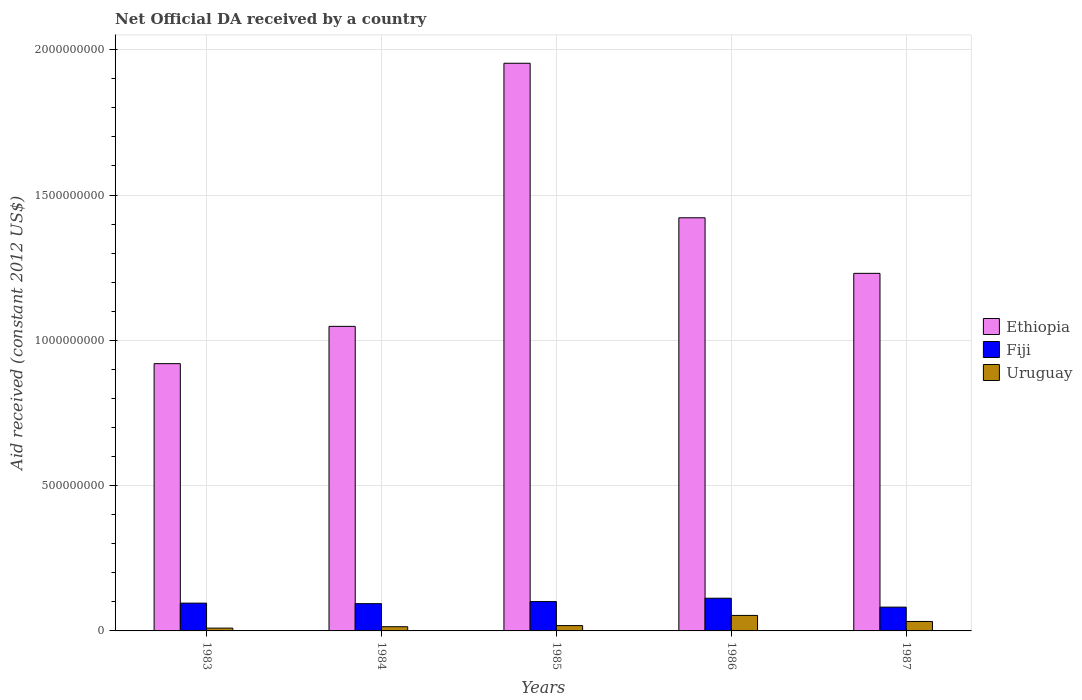How many groups of bars are there?
Give a very brief answer. 5. Are the number of bars on each tick of the X-axis equal?
Give a very brief answer. Yes. How many bars are there on the 2nd tick from the right?
Give a very brief answer. 3. What is the label of the 3rd group of bars from the left?
Give a very brief answer. 1985. In how many cases, is the number of bars for a given year not equal to the number of legend labels?
Give a very brief answer. 0. What is the net official development assistance aid received in Ethiopia in 1985?
Provide a succinct answer. 1.95e+09. Across all years, what is the maximum net official development assistance aid received in Ethiopia?
Give a very brief answer. 1.95e+09. Across all years, what is the minimum net official development assistance aid received in Ethiopia?
Give a very brief answer. 9.20e+08. In which year was the net official development assistance aid received in Fiji maximum?
Provide a succinct answer. 1986. What is the total net official development assistance aid received in Uruguay in the graph?
Offer a very short reply. 1.28e+08. What is the difference between the net official development assistance aid received in Fiji in 1983 and that in 1987?
Provide a succinct answer. 1.38e+07. What is the difference between the net official development assistance aid received in Ethiopia in 1985 and the net official development assistance aid received in Uruguay in 1984?
Make the answer very short. 1.94e+09. What is the average net official development assistance aid received in Fiji per year?
Your answer should be very brief. 9.70e+07. In the year 1987, what is the difference between the net official development assistance aid received in Uruguay and net official development assistance aid received in Ethiopia?
Provide a short and direct response. -1.20e+09. In how many years, is the net official development assistance aid received in Ethiopia greater than 800000000 US$?
Give a very brief answer. 5. What is the ratio of the net official development assistance aid received in Uruguay in 1983 to that in 1985?
Ensure brevity in your answer.  0.53. Is the net official development assistance aid received in Fiji in 1985 less than that in 1987?
Provide a succinct answer. No. Is the difference between the net official development assistance aid received in Uruguay in 1983 and 1986 greater than the difference between the net official development assistance aid received in Ethiopia in 1983 and 1986?
Provide a succinct answer. Yes. What is the difference between the highest and the second highest net official development assistance aid received in Fiji?
Provide a succinct answer. 1.15e+07. What is the difference between the highest and the lowest net official development assistance aid received in Uruguay?
Make the answer very short. 4.37e+07. Is the sum of the net official development assistance aid received in Fiji in 1986 and 1987 greater than the maximum net official development assistance aid received in Uruguay across all years?
Offer a terse response. Yes. What does the 1st bar from the left in 1984 represents?
Your answer should be very brief. Ethiopia. What does the 2nd bar from the right in 1986 represents?
Ensure brevity in your answer.  Fiji. Is it the case that in every year, the sum of the net official development assistance aid received in Fiji and net official development assistance aid received in Uruguay is greater than the net official development assistance aid received in Ethiopia?
Give a very brief answer. No. How many bars are there?
Make the answer very short. 15. How many years are there in the graph?
Your answer should be very brief. 5. Does the graph contain any zero values?
Offer a terse response. No. What is the title of the graph?
Your answer should be compact. Net Official DA received by a country. Does "Zambia" appear as one of the legend labels in the graph?
Your response must be concise. No. What is the label or title of the X-axis?
Your answer should be compact. Years. What is the label or title of the Y-axis?
Keep it short and to the point. Aid received (constant 2012 US$). What is the Aid received (constant 2012 US$) in Ethiopia in 1983?
Give a very brief answer. 9.20e+08. What is the Aid received (constant 2012 US$) of Fiji in 1983?
Ensure brevity in your answer.  9.56e+07. What is the Aid received (constant 2012 US$) in Uruguay in 1983?
Ensure brevity in your answer.  9.64e+06. What is the Aid received (constant 2012 US$) in Ethiopia in 1984?
Ensure brevity in your answer.  1.05e+09. What is the Aid received (constant 2012 US$) in Fiji in 1984?
Your response must be concise. 9.38e+07. What is the Aid received (constant 2012 US$) of Uruguay in 1984?
Your answer should be compact. 1.44e+07. What is the Aid received (constant 2012 US$) in Ethiopia in 1985?
Give a very brief answer. 1.95e+09. What is the Aid received (constant 2012 US$) in Fiji in 1985?
Provide a succinct answer. 1.01e+08. What is the Aid received (constant 2012 US$) in Uruguay in 1985?
Offer a very short reply. 1.83e+07. What is the Aid received (constant 2012 US$) in Ethiopia in 1986?
Ensure brevity in your answer.  1.42e+09. What is the Aid received (constant 2012 US$) of Fiji in 1986?
Your answer should be very brief. 1.13e+08. What is the Aid received (constant 2012 US$) in Uruguay in 1986?
Ensure brevity in your answer.  5.34e+07. What is the Aid received (constant 2012 US$) of Ethiopia in 1987?
Offer a very short reply. 1.23e+09. What is the Aid received (constant 2012 US$) of Fiji in 1987?
Offer a terse response. 8.18e+07. What is the Aid received (constant 2012 US$) in Uruguay in 1987?
Offer a very short reply. 3.25e+07. Across all years, what is the maximum Aid received (constant 2012 US$) in Ethiopia?
Your response must be concise. 1.95e+09. Across all years, what is the maximum Aid received (constant 2012 US$) of Fiji?
Your response must be concise. 1.13e+08. Across all years, what is the maximum Aid received (constant 2012 US$) in Uruguay?
Offer a terse response. 5.34e+07. Across all years, what is the minimum Aid received (constant 2012 US$) of Ethiopia?
Provide a short and direct response. 9.20e+08. Across all years, what is the minimum Aid received (constant 2012 US$) of Fiji?
Your response must be concise. 8.18e+07. Across all years, what is the minimum Aid received (constant 2012 US$) of Uruguay?
Offer a very short reply. 9.64e+06. What is the total Aid received (constant 2012 US$) in Ethiopia in the graph?
Your answer should be very brief. 6.57e+09. What is the total Aid received (constant 2012 US$) of Fiji in the graph?
Make the answer very short. 4.85e+08. What is the total Aid received (constant 2012 US$) of Uruguay in the graph?
Your answer should be very brief. 1.28e+08. What is the difference between the Aid received (constant 2012 US$) in Ethiopia in 1983 and that in 1984?
Keep it short and to the point. -1.28e+08. What is the difference between the Aid received (constant 2012 US$) of Fiji in 1983 and that in 1984?
Provide a succinct answer. 1.80e+06. What is the difference between the Aid received (constant 2012 US$) in Uruguay in 1983 and that in 1984?
Offer a terse response. -4.81e+06. What is the difference between the Aid received (constant 2012 US$) in Ethiopia in 1983 and that in 1985?
Provide a succinct answer. -1.03e+09. What is the difference between the Aid received (constant 2012 US$) in Fiji in 1983 and that in 1985?
Your answer should be compact. -5.38e+06. What is the difference between the Aid received (constant 2012 US$) of Uruguay in 1983 and that in 1985?
Your response must be concise. -8.65e+06. What is the difference between the Aid received (constant 2012 US$) in Ethiopia in 1983 and that in 1986?
Provide a short and direct response. -5.02e+08. What is the difference between the Aid received (constant 2012 US$) in Fiji in 1983 and that in 1986?
Your answer should be very brief. -1.69e+07. What is the difference between the Aid received (constant 2012 US$) of Uruguay in 1983 and that in 1986?
Offer a terse response. -4.37e+07. What is the difference between the Aid received (constant 2012 US$) in Ethiopia in 1983 and that in 1987?
Your answer should be very brief. -3.11e+08. What is the difference between the Aid received (constant 2012 US$) in Fiji in 1983 and that in 1987?
Offer a terse response. 1.38e+07. What is the difference between the Aid received (constant 2012 US$) of Uruguay in 1983 and that in 1987?
Provide a short and direct response. -2.29e+07. What is the difference between the Aid received (constant 2012 US$) in Ethiopia in 1984 and that in 1985?
Give a very brief answer. -9.05e+08. What is the difference between the Aid received (constant 2012 US$) in Fiji in 1984 and that in 1985?
Keep it short and to the point. -7.18e+06. What is the difference between the Aid received (constant 2012 US$) in Uruguay in 1984 and that in 1985?
Your answer should be compact. -3.84e+06. What is the difference between the Aid received (constant 2012 US$) of Ethiopia in 1984 and that in 1986?
Provide a short and direct response. -3.74e+08. What is the difference between the Aid received (constant 2012 US$) in Fiji in 1984 and that in 1986?
Keep it short and to the point. -1.87e+07. What is the difference between the Aid received (constant 2012 US$) of Uruguay in 1984 and that in 1986?
Offer a terse response. -3.89e+07. What is the difference between the Aid received (constant 2012 US$) in Ethiopia in 1984 and that in 1987?
Keep it short and to the point. -1.82e+08. What is the difference between the Aid received (constant 2012 US$) of Fiji in 1984 and that in 1987?
Ensure brevity in your answer.  1.20e+07. What is the difference between the Aid received (constant 2012 US$) of Uruguay in 1984 and that in 1987?
Keep it short and to the point. -1.81e+07. What is the difference between the Aid received (constant 2012 US$) of Ethiopia in 1985 and that in 1986?
Ensure brevity in your answer.  5.32e+08. What is the difference between the Aid received (constant 2012 US$) in Fiji in 1985 and that in 1986?
Keep it short and to the point. -1.15e+07. What is the difference between the Aid received (constant 2012 US$) in Uruguay in 1985 and that in 1986?
Offer a terse response. -3.51e+07. What is the difference between the Aid received (constant 2012 US$) in Ethiopia in 1985 and that in 1987?
Offer a terse response. 7.23e+08. What is the difference between the Aid received (constant 2012 US$) in Fiji in 1985 and that in 1987?
Give a very brief answer. 1.92e+07. What is the difference between the Aid received (constant 2012 US$) in Uruguay in 1985 and that in 1987?
Offer a terse response. -1.42e+07. What is the difference between the Aid received (constant 2012 US$) in Ethiopia in 1986 and that in 1987?
Give a very brief answer. 1.91e+08. What is the difference between the Aid received (constant 2012 US$) of Fiji in 1986 and that in 1987?
Ensure brevity in your answer.  3.07e+07. What is the difference between the Aid received (constant 2012 US$) of Uruguay in 1986 and that in 1987?
Provide a succinct answer. 2.08e+07. What is the difference between the Aid received (constant 2012 US$) in Ethiopia in 1983 and the Aid received (constant 2012 US$) in Fiji in 1984?
Keep it short and to the point. 8.26e+08. What is the difference between the Aid received (constant 2012 US$) in Ethiopia in 1983 and the Aid received (constant 2012 US$) in Uruguay in 1984?
Provide a succinct answer. 9.05e+08. What is the difference between the Aid received (constant 2012 US$) in Fiji in 1983 and the Aid received (constant 2012 US$) in Uruguay in 1984?
Ensure brevity in your answer.  8.12e+07. What is the difference between the Aid received (constant 2012 US$) in Ethiopia in 1983 and the Aid received (constant 2012 US$) in Fiji in 1985?
Your answer should be compact. 8.19e+08. What is the difference between the Aid received (constant 2012 US$) in Ethiopia in 1983 and the Aid received (constant 2012 US$) in Uruguay in 1985?
Make the answer very short. 9.01e+08. What is the difference between the Aid received (constant 2012 US$) of Fiji in 1983 and the Aid received (constant 2012 US$) of Uruguay in 1985?
Make the answer very short. 7.73e+07. What is the difference between the Aid received (constant 2012 US$) in Ethiopia in 1983 and the Aid received (constant 2012 US$) in Fiji in 1986?
Offer a terse response. 8.07e+08. What is the difference between the Aid received (constant 2012 US$) of Ethiopia in 1983 and the Aid received (constant 2012 US$) of Uruguay in 1986?
Offer a very short reply. 8.66e+08. What is the difference between the Aid received (constant 2012 US$) of Fiji in 1983 and the Aid received (constant 2012 US$) of Uruguay in 1986?
Your answer should be compact. 4.22e+07. What is the difference between the Aid received (constant 2012 US$) of Ethiopia in 1983 and the Aid received (constant 2012 US$) of Fiji in 1987?
Your answer should be compact. 8.38e+08. What is the difference between the Aid received (constant 2012 US$) in Ethiopia in 1983 and the Aid received (constant 2012 US$) in Uruguay in 1987?
Give a very brief answer. 8.87e+08. What is the difference between the Aid received (constant 2012 US$) of Fiji in 1983 and the Aid received (constant 2012 US$) of Uruguay in 1987?
Keep it short and to the point. 6.31e+07. What is the difference between the Aid received (constant 2012 US$) in Ethiopia in 1984 and the Aid received (constant 2012 US$) in Fiji in 1985?
Ensure brevity in your answer.  9.47e+08. What is the difference between the Aid received (constant 2012 US$) of Ethiopia in 1984 and the Aid received (constant 2012 US$) of Uruguay in 1985?
Offer a terse response. 1.03e+09. What is the difference between the Aid received (constant 2012 US$) in Fiji in 1984 and the Aid received (constant 2012 US$) in Uruguay in 1985?
Provide a short and direct response. 7.55e+07. What is the difference between the Aid received (constant 2012 US$) of Ethiopia in 1984 and the Aid received (constant 2012 US$) of Fiji in 1986?
Offer a very short reply. 9.35e+08. What is the difference between the Aid received (constant 2012 US$) in Ethiopia in 1984 and the Aid received (constant 2012 US$) in Uruguay in 1986?
Make the answer very short. 9.95e+08. What is the difference between the Aid received (constant 2012 US$) in Fiji in 1984 and the Aid received (constant 2012 US$) in Uruguay in 1986?
Keep it short and to the point. 4.04e+07. What is the difference between the Aid received (constant 2012 US$) in Ethiopia in 1984 and the Aid received (constant 2012 US$) in Fiji in 1987?
Offer a terse response. 9.66e+08. What is the difference between the Aid received (constant 2012 US$) in Ethiopia in 1984 and the Aid received (constant 2012 US$) in Uruguay in 1987?
Offer a very short reply. 1.02e+09. What is the difference between the Aid received (constant 2012 US$) of Fiji in 1984 and the Aid received (constant 2012 US$) of Uruguay in 1987?
Provide a succinct answer. 6.13e+07. What is the difference between the Aid received (constant 2012 US$) of Ethiopia in 1985 and the Aid received (constant 2012 US$) of Fiji in 1986?
Make the answer very short. 1.84e+09. What is the difference between the Aid received (constant 2012 US$) of Ethiopia in 1985 and the Aid received (constant 2012 US$) of Uruguay in 1986?
Your response must be concise. 1.90e+09. What is the difference between the Aid received (constant 2012 US$) of Fiji in 1985 and the Aid received (constant 2012 US$) of Uruguay in 1986?
Offer a terse response. 4.76e+07. What is the difference between the Aid received (constant 2012 US$) in Ethiopia in 1985 and the Aid received (constant 2012 US$) in Fiji in 1987?
Keep it short and to the point. 1.87e+09. What is the difference between the Aid received (constant 2012 US$) in Ethiopia in 1985 and the Aid received (constant 2012 US$) in Uruguay in 1987?
Give a very brief answer. 1.92e+09. What is the difference between the Aid received (constant 2012 US$) of Fiji in 1985 and the Aid received (constant 2012 US$) of Uruguay in 1987?
Your response must be concise. 6.85e+07. What is the difference between the Aid received (constant 2012 US$) in Ethiopia in 1986 and the Aid received (constant 2012 US$) in Fiji in 1987?
Make the answer very short. 1.34e+09. What is the difference between the Aid received (constant 2012 US$) in Ethiopia in 1986 and the Aid received (constant 2012 US$) in Uruguay in 1987?
Ensure brevity in your answer.  1.39e+09. What is the difference between the Aid received (constant 2012 US$) in Fiji in 1986 and the Aid received (constant 2012 US$) in Uruguay in 1987?
Your response must be concise. 8.00e+07. What is the average Aid received (constant 2012 US$) in Ethiopia per year?
Your response must be concise. 1.31e+09. What is the average Aid received (constant 2012 US$) of Fiji per year?
Your answer should be compact. 9.70e+07. What is the average Aid received (constant 2012 US$) of Uruguay per year?
Your answer should be compact. 2.57e+07. In the year 1983, what is the difference between the Aid received (constant 2012 US$) of Ethiopia and Aid received (constant 2012 US$) of Fiji?
Keep it short and to the point. 8.24e+08. In the year 1983, what is the difference between the Aid received (constant 2012 US$) in Ethiopia and Aid received (constant 2012 US$) in Uruguay?
Your answer should be compact. 9.10e+08. In the year 1983, what is the difference between the Aid received (constant 2012 US$) in Fiji and Aid received (constant 2012 US$) in Uruguay?
Make the answer very short. 8.60e+07. In the year 1984, what is the difference between the Aid received (constant 2012 US$) in Ethiopia and Aid received (constant 2012 US$) in Fiji?
Provide a short and direct response. 9.54e+08. In the year 1984, what is the difference between the Aid received (constant 2012 US$) of Ethiopia and Aid received (constant 2012 US$) of Uruguay?
Provide a short and direct response. 1.03e+09. In the year 1984, what is the difference between the Aid received (constant 2012 US$) of Fiji and Aid received (constant 2012 US$) of Uruguay?
Offer a very short reply. 7.94e+07. In the year 1985, what is the difference between the Aid received (constant 2012 US$) of Ethiopia and Aid received (constant 2012 US$) of Fiji?
Your answer should be very brief. 1.85e+09. In the year 1985, what is the difference between the Aid received (constant 2012 US$) in Ethiopia and Aid received (constant 2012 US$) in Uruguay?
Keep it short and to the point. 1.94e+09. In the year 1985, what is the difference between the Aid received (constant 2012 US$) in Fiji and Aid received (constant 2012 US$) in Uruguay?
Provide a short and direct response. 8.27e+07. In the year 1986, what is the difference between the Aid received (constant 2012 US$) in Ethiopia and Aid received (constant 2012 US$) in Fiji?
Make the answer very short. 1.31e+09. In the year 1986, what is the difference between the Aid received (constant 2012 US$) in Ethiopia and Aid received (constant 2012 US$) in Uruguay?
Keep it short and to the point. 1.37e+09. In the year 1986, what is the difference between the Aid received (constant 2012 US$) of Fiji and Aid received (constant 2012 US$) of Uruguay?
Ensure brevity in your answer.  5.92e+07. In the year 1987, what is the difference between the Aid received (constant 2012 US$) of Ethiopia and Aid received (constant 2012 US$) of Fiji?
Keep it short and to the point. 1.15e+09. In the year 1987, what is the difference between the Aid received (constant 2012 US$) of Ethiopia and Aid received (constant 2012 US$) of Uruguay?
Your answer should be compact. 1.20e+09. In the year 1987, what is the difference between the Aid received (constant 2012 US$) of Fiji and Aid received (constant 2012 US$) of Uruguay?
Make the answer very short. 4.93e+07. What is the ratio of the Aid received (constant 2012 US$) in Ethiopia in 1983 to that in 1984?
Make the answer very short. 0.88. What is the ratio of the Aid received (constant 2012 US$) of Fiji in 1983 to that in 1984?
Your answer should be very brief. 1.02. What is the ratio of the Aid received (constant 2012 US$) in Uruguay in 1983 to that in 1984?
Offer a terse response. 0.67. What is the ratio of the Aid received (constant 2012 US$) of Ethiopia in 1983 to that in 1985?
Offer a very short reply. 0.47. What is the ratio of the Aid received (constant 2012 US$) in Fiji in 1983 to that in 1985?
Make the answer very short. 0.95. What is the ratio of the Aid received (constant 2012 US$) of Uruguay in 1983 to that in 1985?
Offer a terse response. 0.53. What is the ratio of the Aid received (constant 2012 US$) in Ethiopia in 1983 to that in 1986?
Offer a terse response. 0.65. What is the ratio of the Aid received (constant 2012 US$) in Fiji in 1983 to that in 1986?
Provide a succinct answer. 0.85. What is the ratio of the Aid received (constant 2012 US$) in Uruguay in 1983 to that in 1986?
Offer a terse response. 0.18. What is the ratio of the Aid received (constant 2012 US$) in Ethiopia in 1983 to that in 1987?
Your response must be concise. 0.75. What is the ratio of the Aid received (constant 2012 US$) of Fiji in 1983 to that in 1987?
Your answer should be very brief. 1.17. What is the ratio of the Aid received (constant 2012 US$) in Uruguay in 1983 to that in 1987?
Provide a succinct answer. 0.3. What is the ratio of the Aid received (constant 2012 US$) in Ethiopia in 1984 to that in 1985?
Offer a terse response. 0.54. What is the ratio of the Aid received (constant 2012 US$) in Fiji in 1984 to that in 1985?
Provide a short and direct response. 0.93. What is the ratio of the Aid received (constant 2012 US$) of Uruguay in 1984 to that in 1985?
Ensure brevity in your answer.  0.79. What is the ratio of the Aid received (constant 2012 US$) of Ethiopia in 1984 to that in 1986?
Keep it short and to the point. 0.74. What is the ratio of the Aid received (constant 2012 US$) in Fiji in 1984 to that in 1986?
Offer a very short reply. 0.83. What is the ratio of the Aid received (constant 2012 US$) of Uruguay in 1984 to that in 1986?
Provide a succinct answer. 0.27. What is the ratio of the Aid received (constant 2012 US$) of Ethiopia in 1984 to that in 1987?
Provide a succinct answer. 0.85. What is the ratio of the Aid received (constant 2012 US$) in Fiji in 1984 to that in 1987?
Your response must be concise. 1.15. What is the ratio of the Aid received (constant 2012 US$) in Uruguay in 1984 to that in 1987?
Give a very brief answer. 0.44. What is the ratio of the Aid received (constant 2012 US$) of Ethiopia in 1985 to that in 1986?
Offer a very short reply. 1.37. What is the ratio of the Aid received (constant 2012 US$) in Fiji in 1985 to that in 1986?
Keep it short and to the point. 0.9. What is the ratio of the Aid received (constant 2012 US$) of Uruguay in 1985 to that in 1986?
Give a very brief answer. 0.34. What is the ratio of the Aid received (constant 2012 US$) in Ethiopia in 1985 to that in 1987?
Your answer should be very brief. 1.59. What is the ratio of the Aid received (constant 2012 US$) of Fiji in 1985 to that in 1987?
Make the answer very short. 1.23. What is the ratio of the Aid received (constant 2012 US$) of Uruguay in 1985 to that in 1987?
Offer a terse response. 0.56. What is the ratio of the Aid received (constant 2012 US$) of Ethiopia in 1986 to that in 1987?
Provide a succinct answer. 1.16. What is the ratio of the Aid received (constant 2012 US$) of Fiji in 1986 to that in 1987?
Offer a terse response. 1.37. What is the ratio of the Aid received (constant 2012 US$) in Uruguay in 1986 to that in 1987?
Ensure brevity in your answer.  1.64. What is the difference between the highest and the second highest Aid received (constant 2012 US$) in Ethiopia?
Your answer should be very brief. 5.32e+08. What is the difference between the highest and the second highest Aid received (constant 2012 US$) of Fiji?
Provide a short and direct response. 1.15e+07. What is the difference between the highest and the second highest Aid received (constant 2012 US$) of Uruguay?
Your answer should be very brief. 2.08e+07. What is the difference between the highest and the lowest Aid received (constant 2012 US$) in Ethiopia?
Your response must be concise. 1.03e+09. What is the difference between the highest and the lowest Aid received (constant 2012 US$) of Fiji?
Provide a short and direct response. 3.07e+07. What is the difference between the highest and the lowest Aid received (constant 2012 US$) in Uruguay?
Give a very brief answer. 4.37e+07. 